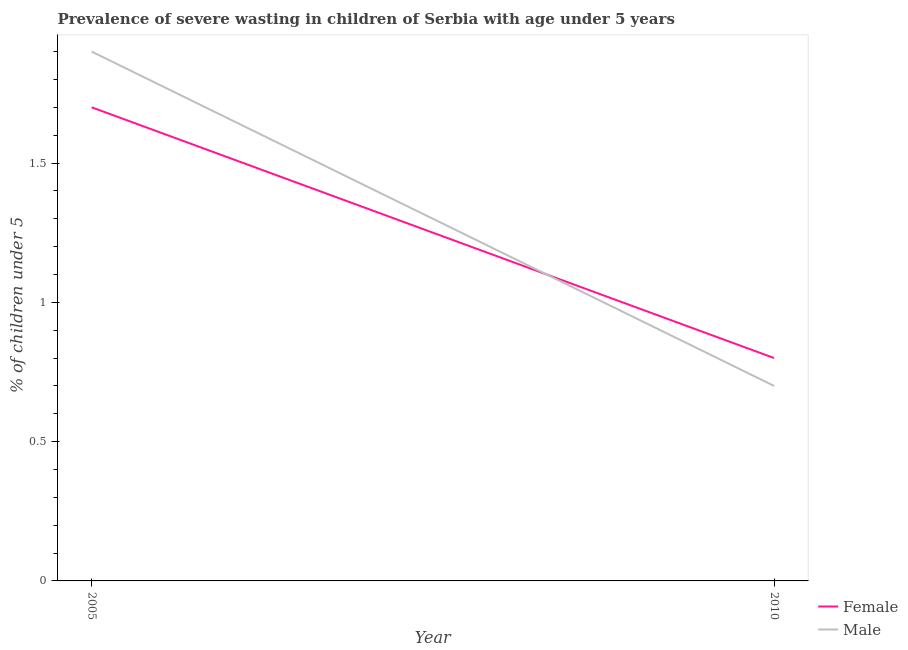How many different coloured lines are there?
Make the answer very short. 2. Does the line corresponding to percentage of undernourished female children intersect with the line corresponding to percentage of undernourished male children?
Provide a succinct answer. Yes. What is the percentage of undernourished male children in 2005?
Provide a succinct answer. 1.9. Across all years, what is the maximum percentage of undernourished male children?
Provide a succinct answer. 1.9. Across all years, what is the minimum percentage of undernourished male children?
Your answer should be compact. 0.7. What is the total percentage of undernourished male children in the graph?
Keep it short and to the point. 2.6. What is the difference between the percentage of undernourished female children in 2005 and that in 2010?
Ensure brevity in your answer.  0.9. What is the difference between the percentage of undernourished male children in 2005 and the percentage of undernourished female children in 2010?
Keep it short and to the point. 1.1. What is the average percentage of undernourished male children per year?
Keep it short and to the point. 1.3. In the year 2005, what is the difference between the percentage of undernourished female children and percentage of undernourished male children?
Keep it short and to the point. -0.2. What is the ratio of the percentage of undernourished male children in 2005 to that in 2010?
Provide a short and direct response. 2.71. Does the percentage of undernourished male children monotonically increase over the years?
Provide a short and direct response. No. Is the percentage of undernourished male children strictly greater than the percentage of undernourished female children over the years?
Ensure brevity in your answer.  No. Is the percentage of undernourished female children strictly less than the percentage of undernourished male children over the years?
Give a very brief answer. No. How many lines are there?
Make the answer very short. 2. How many years are there in the graph?
Offer a terse response. 2. How many legend labels are there?
Your answer should be compact. 2. What is the title of the graph?
Give a very brief answer. Prevalence of severe wasting in children of Serbia with age under 5 years. Does "Register a business" appear as one of the legend labels in the graph?
Your answer should be compact. No. What is the label or title of the Y-axis?
Offer a terse response.  % of children under 5. What is the  % of children under 5 of Female in 2005?
Offer a very short reply. 1.7. What is the  % of children under 5 of Male in 2005?
Ensure brevity in your answer.  1.9. What is the  % of children under 5 in Female in 2010?
Your answer should be compact. 0.8. What is the  % of children under 5 of Male in 2010?
Ensure brevity in your answer.  0.7. Across all years, what is the maximum  % of children under 5 of Female?
Keep it short and to the point. 1.7. Across all years, what is the maximum  % of children under 5 of Male?
Your response must be concise. 1.9. Across all years, what is the minimum  % of children under 5 in Female?
Make the answer very short. 0.8. Across all years, what is the minimum  % of children under 5 of Male?
Your answer should be very brief. 0.7. What is the total  % of children under 5 in Male in the graph?
Keep it short and to the point. 2.6. What is the difference between the  % of children under 5 of Female in 2005 and that in 2010?
Offer a very short reply. 0.9. What is the difference between the  % of children under 5 of Male in 2005 and that in 2010?
Your answer should be very brief. 1.2. What is the average  % of children under 5 in Male per year?
Give a very brief answer. 1.3. In the year 2005, what is the difference between the  % of children under 5 in Female and  % of children under 5 in Male?
Give a very brief answer. -0.2. In the year 2010, what is the difference between the  % of children under 5 of Female and  % of children under 5 of Male?
Ensure brevity in your answer.  0.1. What is the ratio of the  % of children under 5 of Female in 2005 to that in 2010?
Offer a terse response. 2.12. What is the ratio of the  % of children under 5 of Male in 2005 to that in 2010?
Your response must be concise. 2.71. What is the difference between the highest and the second highest  % of children under 5 in Male?
Offer a very short reply. 1.2. What is the difference between the highest and the lowest  % of children under 5 of Male?
Offer a very short reply. 1.2. 